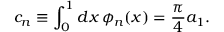<formula> <loc_0><loc_0><loc_500><loc_500>c _ { n } \equiv \int _ { 0 } ^ { 1 } d x \, \phi _ { n } ( x ) = \frac { \pi } { 4 } a _ { 1 } .</formula> 